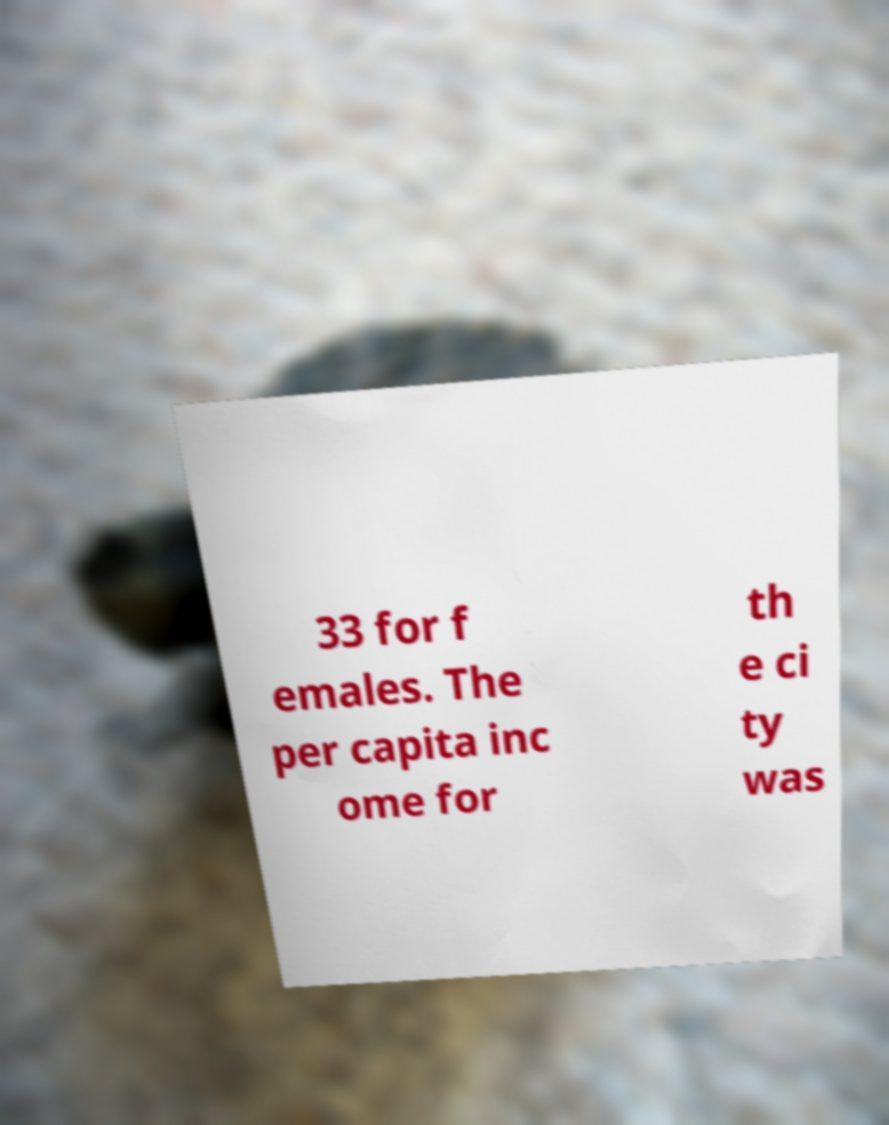There's text embedded in this image that I need extracted. Can you transcribe it verbatim? 33 for f emales. The per capita inc ome for th e ci ty was 